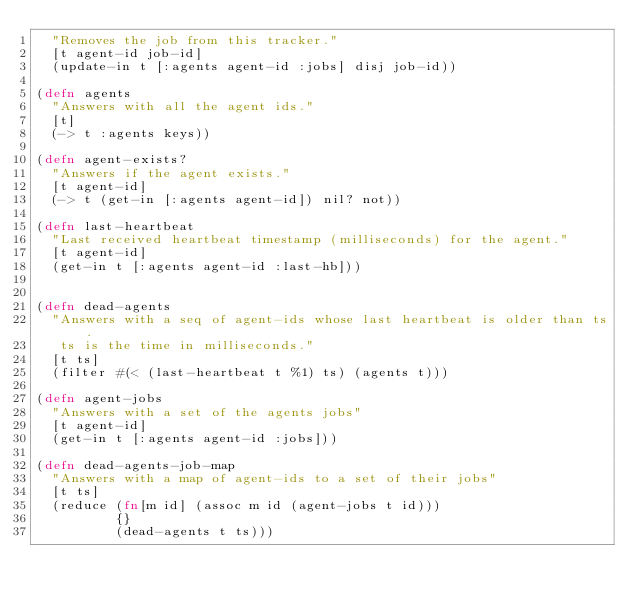Convert code to text. <code><loc_0><loc_0><loc_500><loc_500><_Clojure_>  "Removes the job from this tracker."
  [t agent-id job-id]
  (update-in t [:agents agent-id :jobs] disj job-id))

(defn agents
  "Answers with all the agent ids."
  [t]
  (-> t :agents keys))

(defn agent-exists?
  "Answers if the agent exists."
  [t agent-id]
  (-> t (get-in [:agents agent-id]) nil? not))

(defn last-heartbeat
  "Last received heartbeat timestamp (milliseconds) for the agent."
  [t agent-id]
  (get-in t [:agents agent-id :last-hb]))


(defn dead-agents
  "Answers with a seq of agent-ids whose last heartbeat is older than ts.
   ts is the time in milliseconds."
  [t ts]
  (filter #(< (last-heartbeat t %1) ts) (agents t)))

(defn agent-jobs
  "Answers with a set of the agents jobs"
  [t agent-id]
  (get-in t [:agents agent-id :jobs]))

(defn dead-agents-job-map
  "Answers with a map of agent-ids to a set of their jobs"
  [t ts]
  (reduce (fn[m id] (assoc m id (agent-jobs t id)))
          {}
          (dead-agents t ts)))
</code> 